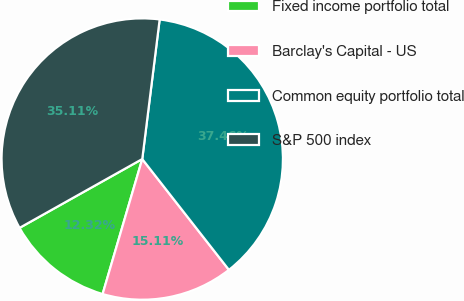Convert chart to OTSL. <chart><loc_0><loc_0><loc_500><loc_500><pie_chart><fcel>Fixed income portfolio total<fcel>Barclay's Capital - US<fcel>Common equity portfolio total<fcel>S&P 500 index<nl><fcel>12.32%<fcel>15.11%<fcel>37.46%<fcel>35.11%<nl></chart> 